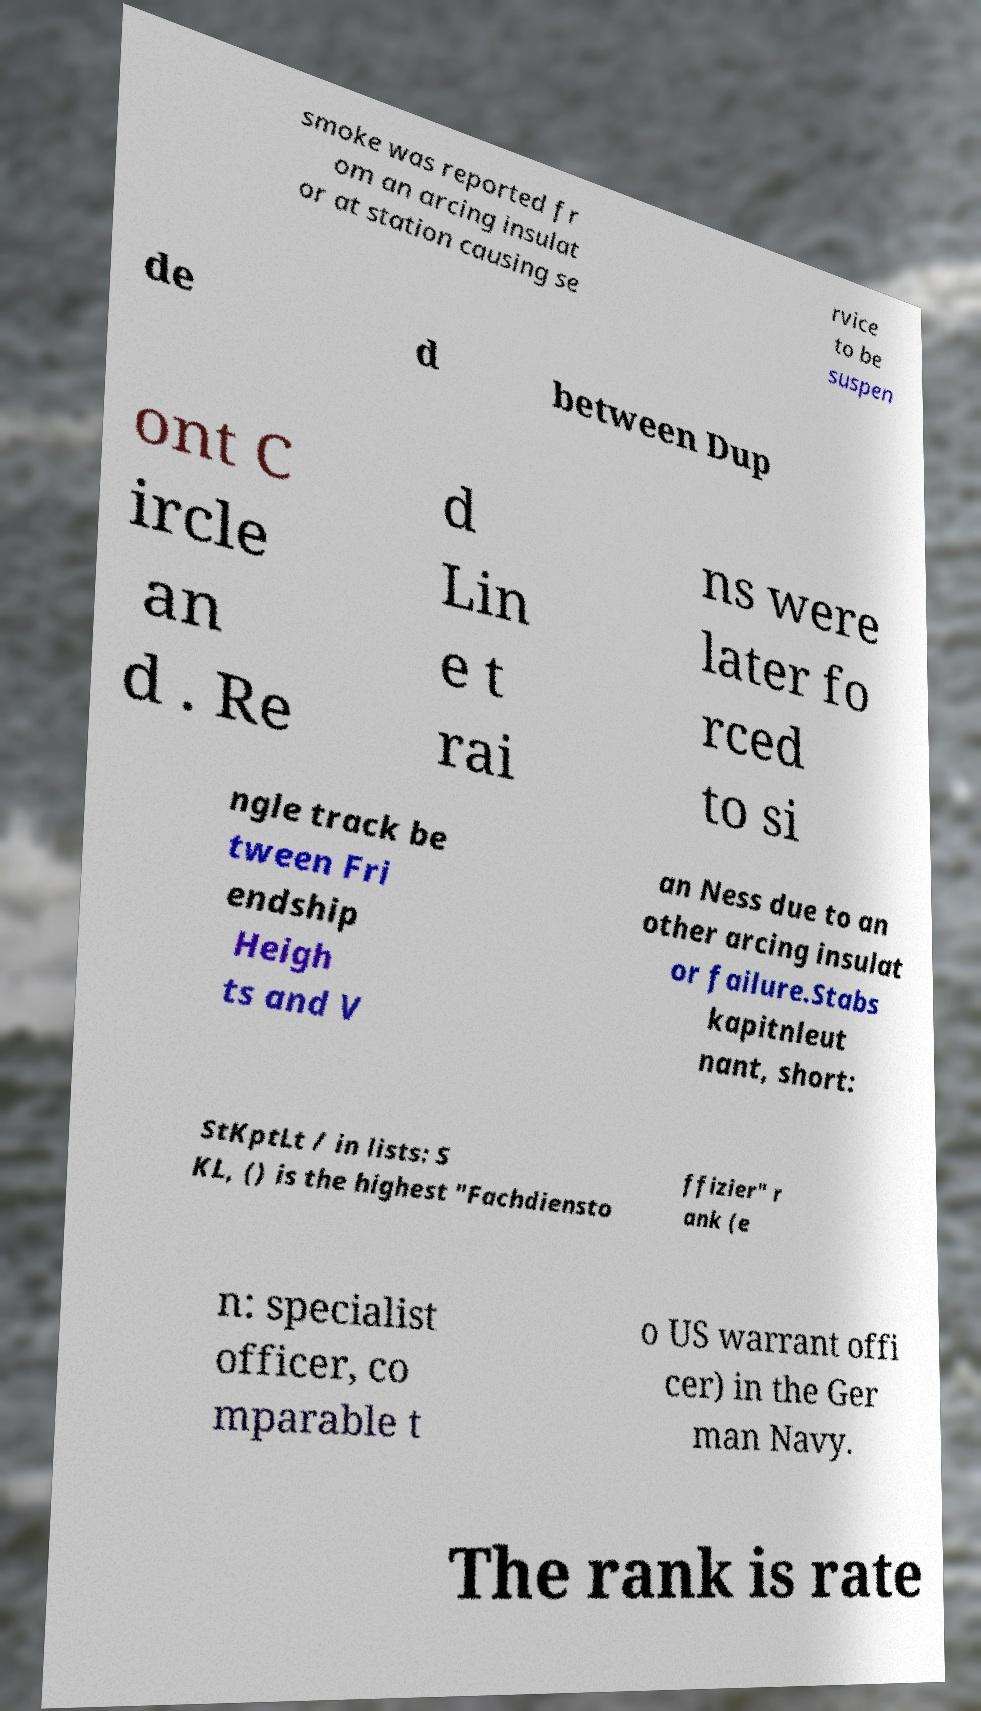Could you assist in decoding the text presented in this image and type it out clearly? smoke was reported fr om an arcing insulat or at station causing se rvice to be suspen de d between Dup ont C ircle an d . Re d Lin e t rai ns were later fo rced to si ngle track be tween Fri endship Heigh ts and V an Ness due to an other arcing insulat or failure.Stabs kapitnleut nant, short: StKptLt / in lists: S KL, () is the highest "Fachdiensto ffizier" r ank (e n: specialist officer, co mparable t o US warrant offi cer) in the Ger man Navy. The rank is rate 